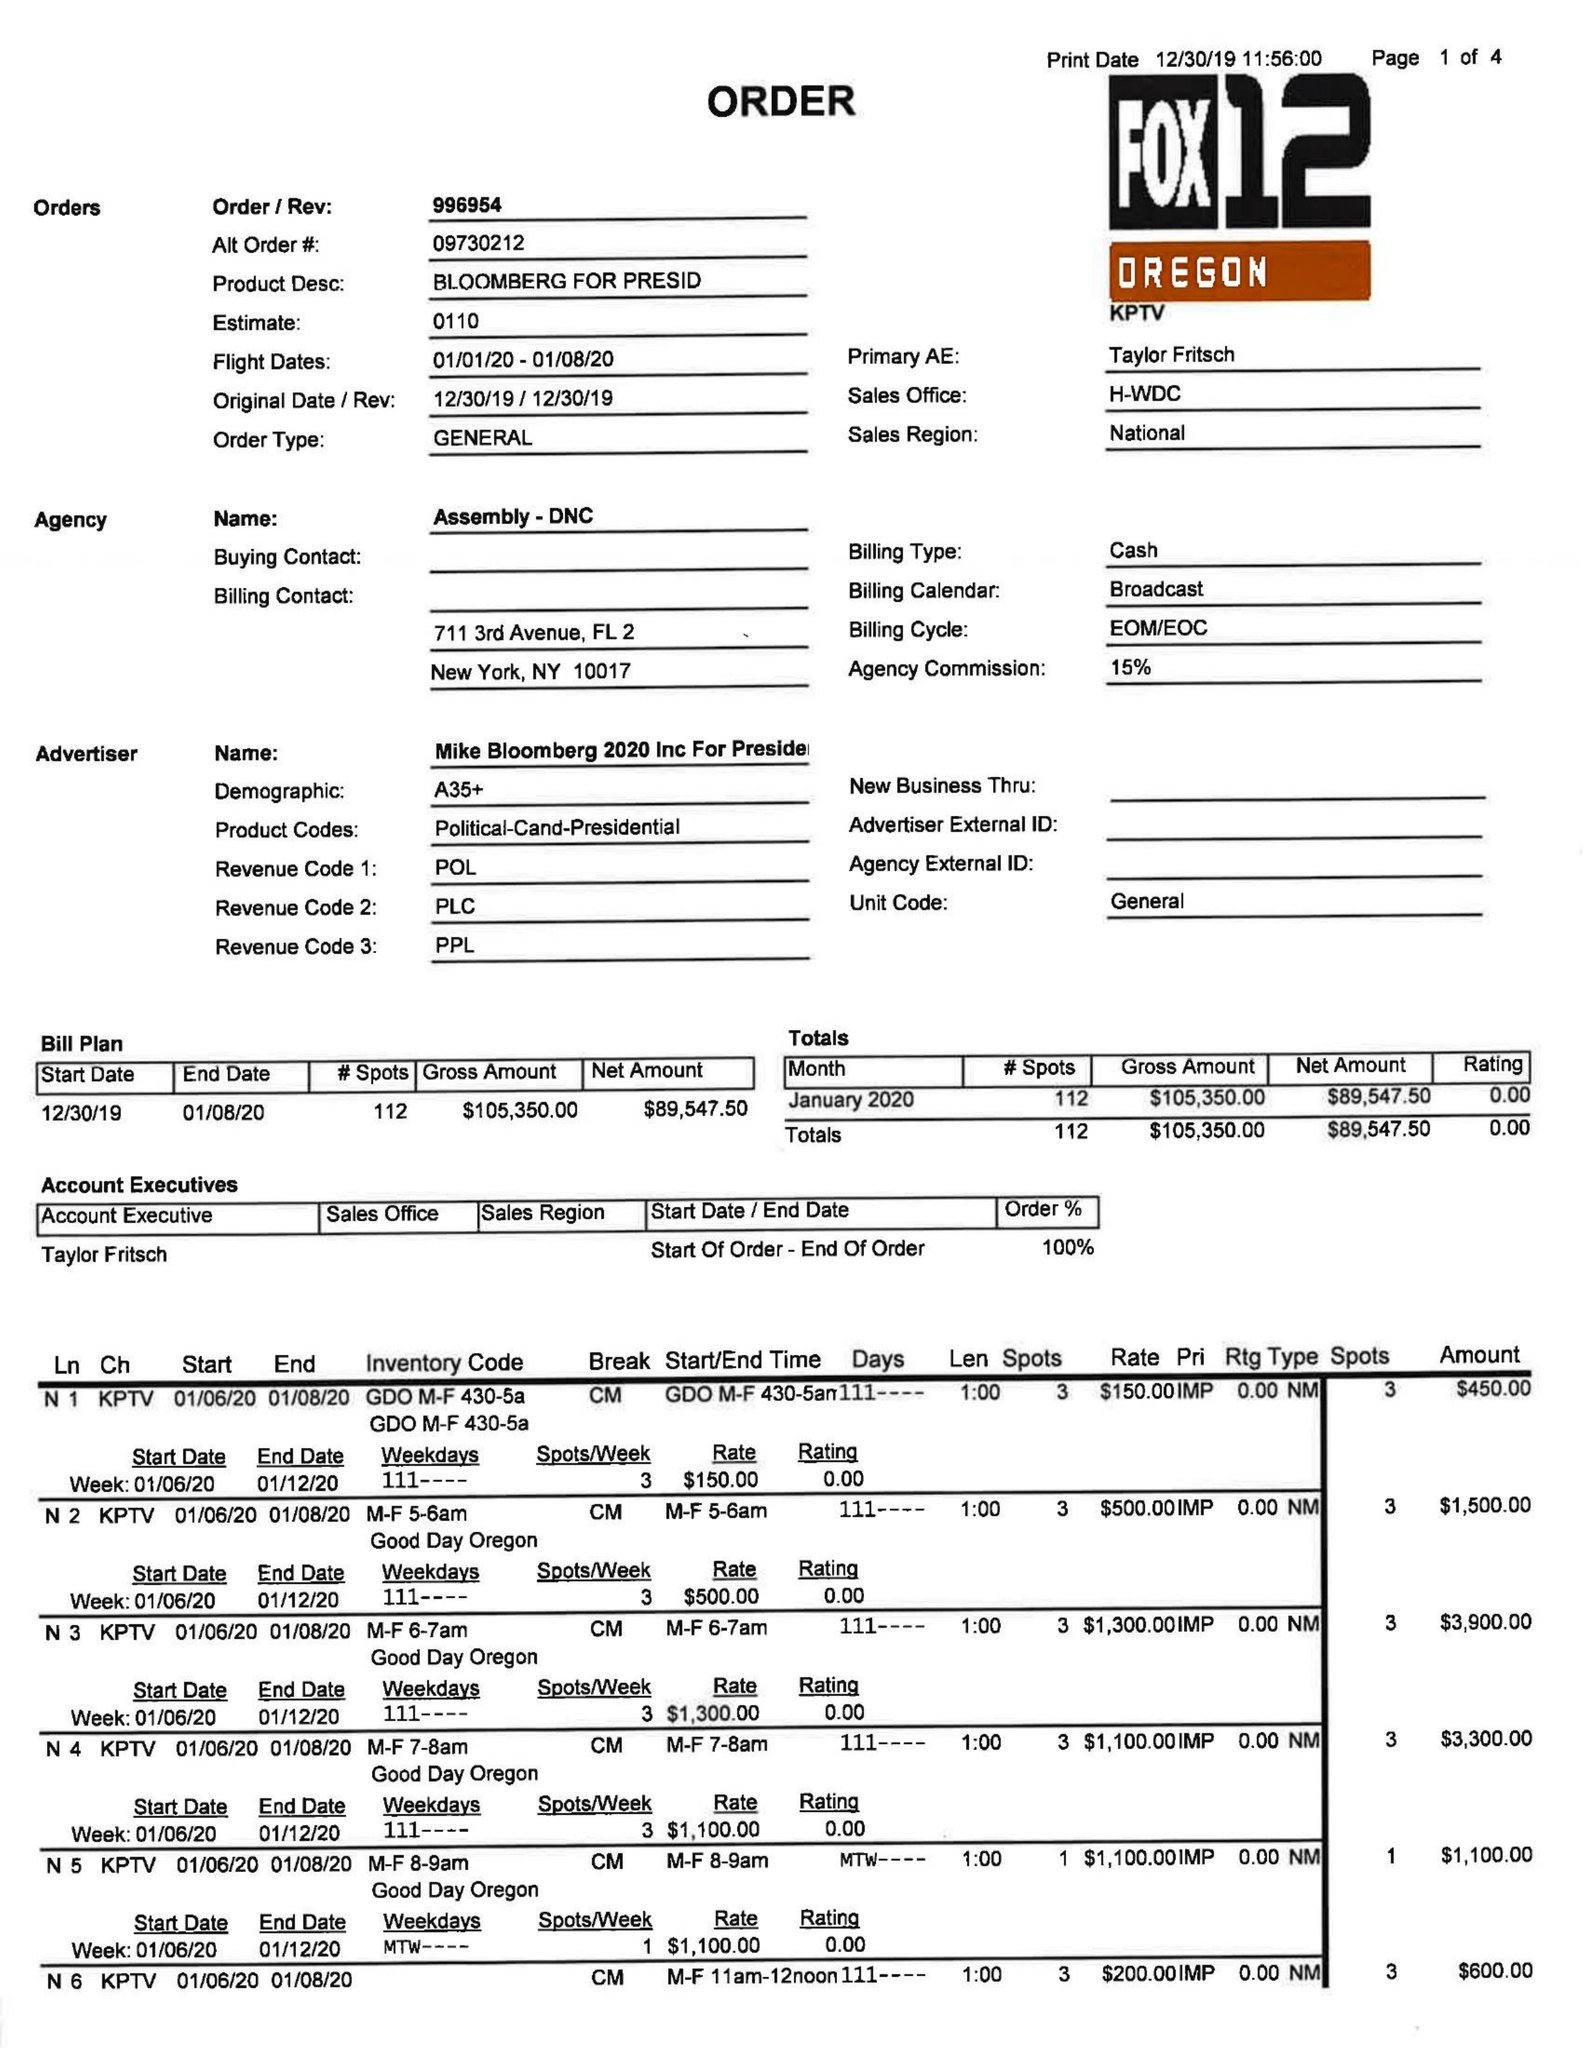What is the value for the flight_from?
Answer the question using a single word or phrase. 01/01/20 